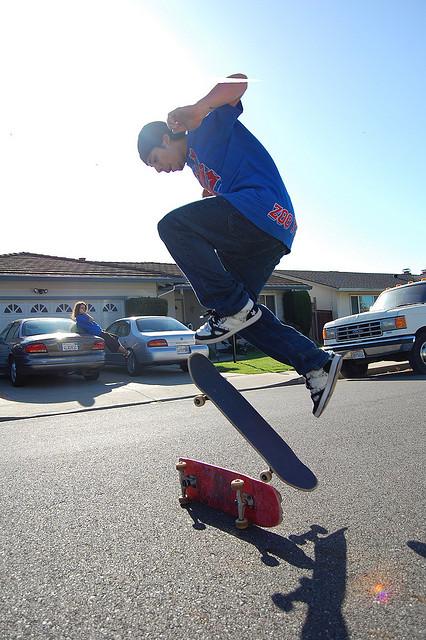Where are the cars parked?
Concise answer only. Driveway. Is the boy skating in an industrial park area?
Short answer required. No. How many feet does the skateboard have touching the skateboard?
Keep it brief. 0. 